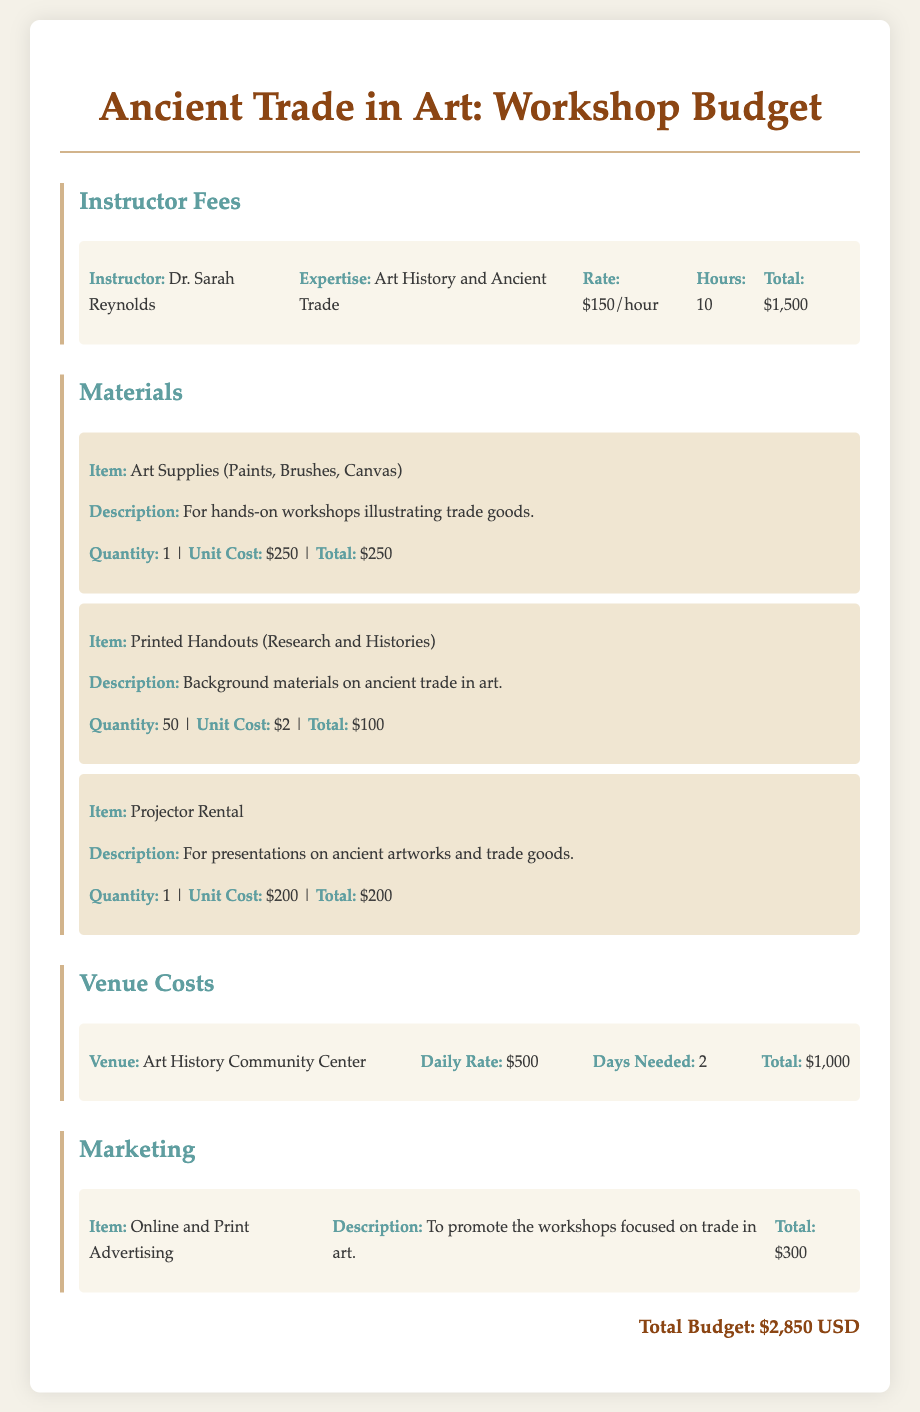What is the total budget for the workshop? The total budget is listed at the end of the document, which adds up all expenses: instructor fees, materials, venue costs, and marketing.
Answer: $2,850 USD Who is the instructor for the workshop? The document specifies the instructor's name at the beginning of the instructor fees section.
Answer: Dr. Sarah Reynolds What is the unit cost of art supplies? The materials section provides the unit cost for art supplies specifically.
Answer: $250 How many printed handouts will be provided? The quantity of printed handouts is stated in the materials section.
Answer: 50 What is the daily rate for the venue? The daily rate for the venue can be found in the venue costs section.
Answer: $500 What is the total amount allocated for marketing? The marketing section lists the total amount designated for advertising the workshops.
Answer: $300 How many hours will the instructor teach? The number of hours the instructor will be providing workshops is mentioned in the instructor fees section.
Answer: 10 Which venue will be used for the workshops? The document specifies the name of the venue located in the venue costs section.
Answer: Art History Community Center What type of materials are included in the workshop? The materials section includes various items used for the workshops, specifically listed in bullet points.
Answer: Art Supplies, Printed Handouts, Projector Rental 